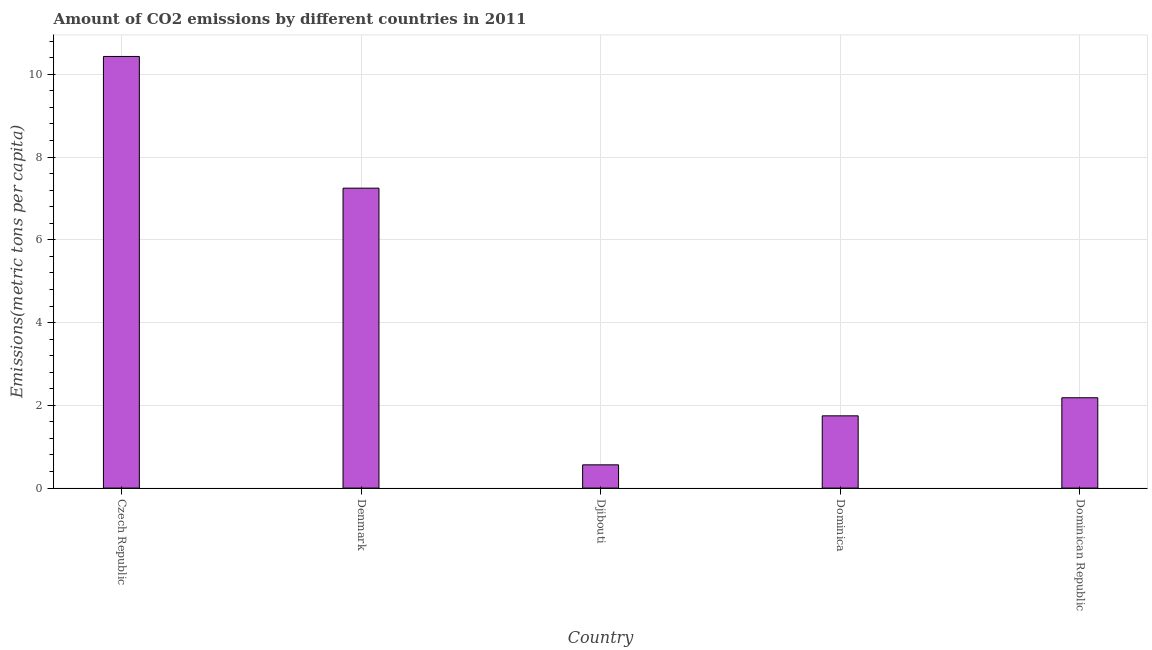Does the graph contain any zero values?
Offer a very short reply. No. Does the graph contain grids?
Your answer should be compact. Yes. What is the title of the graph?
Make the answer very short. Amount of CO2 emissions by different countries in 2011. What is the label or title of the Y-axis?
Your answer should be very brief. Emissions(metric tons per capita). What is the amount of co2 emissions in Czech Republic?
Your response must be concise. 10.43. Across all countries, what is the maximum amount of co2 emissions?
Offer a terse response. 10.43. Across all countries, what is the minimum amount of co2 emissions?
Your answer should be very brief. 0.56. In which country was the amount of co2 emissions maximum?
Your answer should be very brief. Czech Republic. In which country was the amount of co2 emissions minimum?
Provide a short and direct response. Djibouti. What is the sum of the amount of co2 emissions?
Keep it short and to the point. 22.17. What is the difference between the amount of co2 emissions in Czech Republic and Denmark?
Offer a terse response. 3.18. What is the average amount of co2 emissions per country?
Offer a terse response. 4.43. What is the median amount of co2 emissions?
Your response must be concise. 2.18. In how many countries, is the amount of co2 emissions greater than 10.4 metric tons per capita?
Offer a very short reply. 1. What is the ratio of the amount of co2 emissions in Djibouti to that in Dominican Republic?
Provide a short and direct response. 0.26. What is the difference between the highest and the second highest amount of co2 emissions?
Make the answer very short. 3.18. What is the difference between the highest and the lowest amount of co2 emissions?
Provide a succinct answer. 9.87. What is the difference between two consecutive major ticks on the Y-axis?
Offer a terse response. 2. Are the values on the major ticks of Y-axis written in scientific E-notation?
Give a very brief answer. No. What is the Emissions(metric tons per capita) in Czech Republic?
Provide a short and direct response. 10.43. What is the Emissions(metric tons per capita) in Denmark?
Your answer should be very brief. 7.25. What is the Emissions(metric tons per capita) of Djibouti?
Your response must be concise. 0.56. What is the Emissions(metric tons per capita) in Dominica?
Your answer should be very brief. 1.75. What is the Emissions(metric tons per capita) of Dominican Republic?
Make the answer very short. 2.18. What is the difference between the Emissions(metric tons per capita) in Czech Republic and Denmark?
Give a very brief answer. 3.18. What is the difference between the Emissions(metric tons per capita) in Czech Republic and Djibouti?
Give a very brief answer. 9.87. What is the difference between the Emissions(metric tons per capita) in Czech Republic and Dominica?
Provide a succinct answer. 8.68. What is the difference between the Emissions(metric tons per capita) in Czech Republic and Dominican Republic?
Provide a succinct answer. 8.25. What is the difference between the Emissions(metric tons per capita) in Denmark and Djibouti?
Your answer should be compact. 6.69. What is the difference between the Emissions(metric tons per capita) in Denmark and Dominica?
Give a very brief answer. 5.5. What is the difference between the Emissions(metric tons per capita) in Denmark and Dominican Republic?
Offer a terse response. 5.07. What is the difference between the Emissions(metric tons per capita) in Djibouti and Dominica?
Provide a succinct answer. -1.18. What is the difference between the Emissions(metric tons per capita) in Djibouti and Dominican Republic?
Provide a succinct answer. -1.62. What is the difference between the Emissions(metric tons per capita) in Dominica and Dominican Republic?
Make the answer very short. -0.44. What is the ratio of the Emissions(metric tons per capita) in Czech Republic to that in Denmark?
Your answer should be compact. 1.44. What is the ratio of the Emissions(metric tons per capita) in Czech Republic to that in Djibouti?
Keep it short and to the point. 18.56. What is the ratio of the Emissions(metric tons per capita) in Czech Republic to that in Dominica?
Keep it short and to the point. 5.97. What is the ratio of the Emissions(metric tons per capita) in Czech Republic to that in Dominican Republic?
Keep it short and to the point. 4.78. What is the ratio of the Emissions(metric tons per capita) in Denmark to that in Djibouti?
Your response must be concise. 12.9. What is the ratio of the Emissions(metric tons per capita) in Denmark to that in Dominica?
Your answer should be very brief. 4.15. What is the ratio of the Emissions(metric tons per capita) in Denmark to that in Dominican Republic?
Offer a terse response. 3.32. What is the ratio of the Emissions(metric tons per capita) in Djibouti to that in Dominica?
Offer a terse response. 0.32. What is the ratio of the Emissions(metric tons per capita) in Djibouti to that in Dominican Republic?
Ensure brevity in your answer.  0.26. 